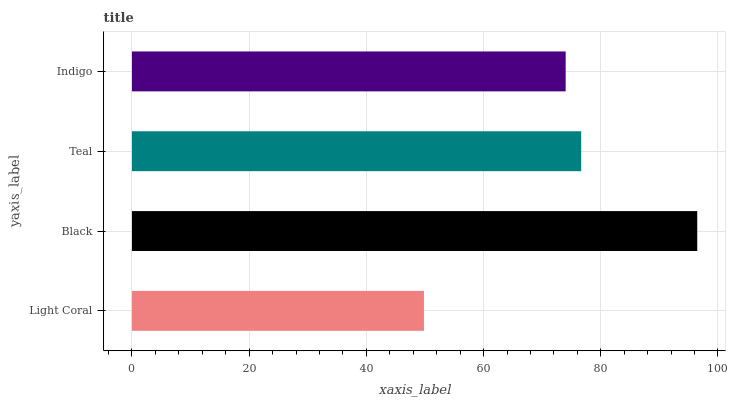Is Light Coral the minimum?
Answer yes or no. Yes. Is Black the maximum?
Answer yes or no. Yes. Is Teal the minimum?
Answer yes or no. No. Is Teal the maximum?
Answer yes or no. No. Is Black greater than Teal?
Answer yes or no. Yes. Is Teal less than Black?
Answer yes or no. Yes. Is Teal greater than Black?
Answer yes or no. No. Is Black less than Teal?
Answer yes or no. No. Is Teal the high median?
Answer yes or no. Yes. Is Indigo the low median?
Answer yes or no. Yes. Is Light Coral the high median?
Answer yes or no. No. Is Light Coral the low median?
Answer yes or no. No. 